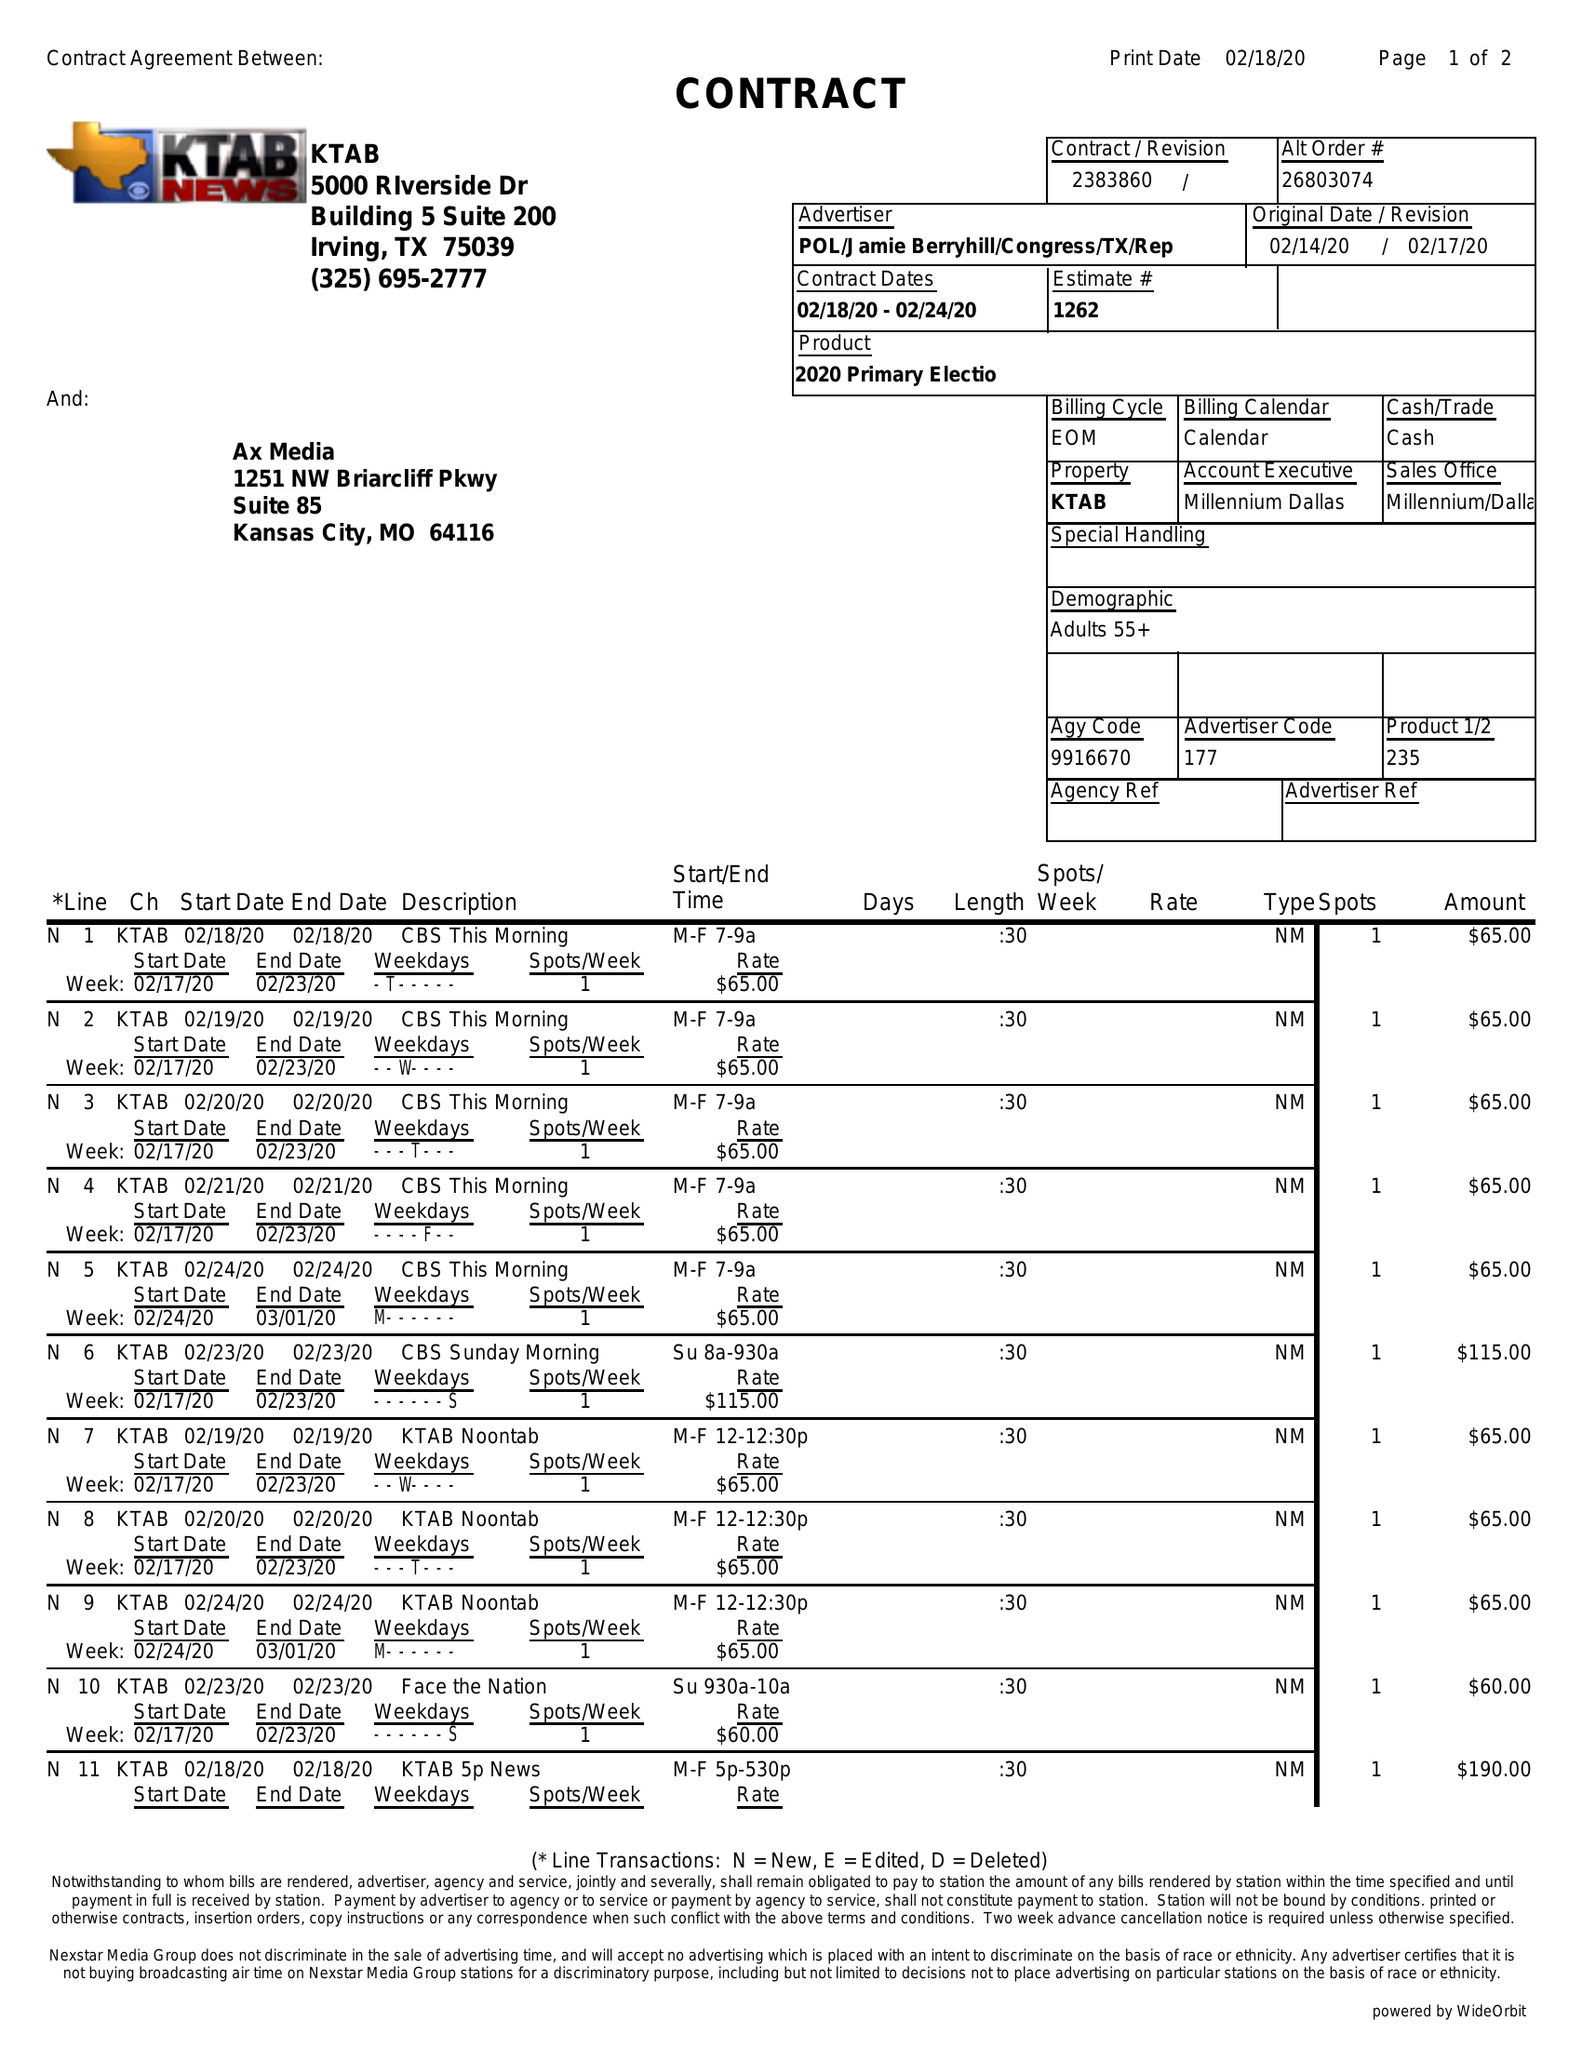What is the value for the flight_from?
Answer the question using a single word or phrase. 02/18/20 